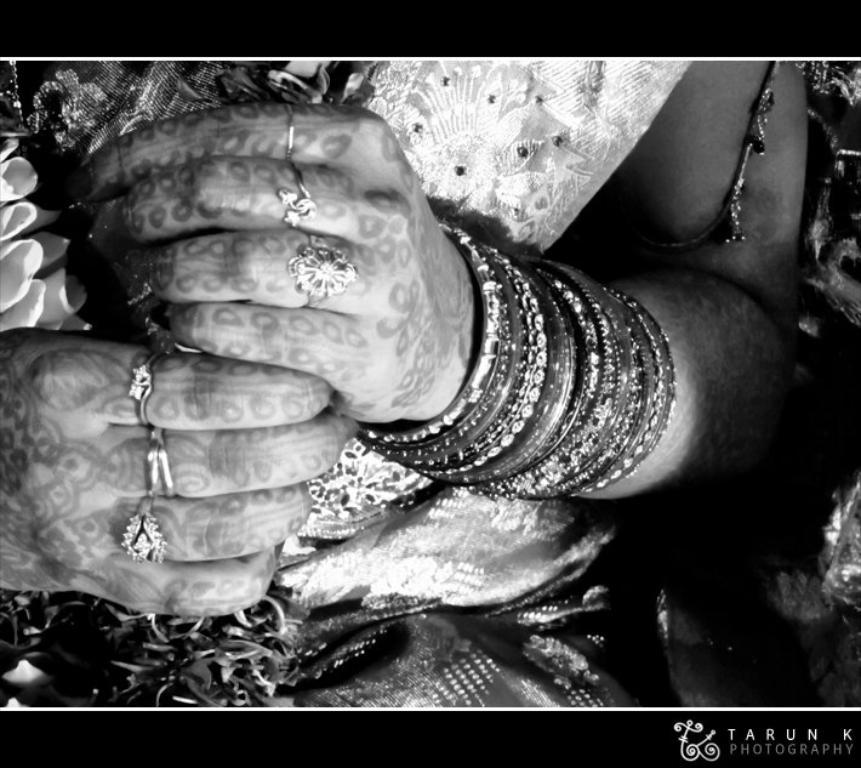What type of clothing is the person wearing in the image? The person is wearing a saree in the image. Are there any accessories visible in the image? Yes, the person is wearing a garland, bangles, and rings. Can you describe the lighting in the image? The image is slightly dark. What type of meat is the person holding in the image? There is no meat present in the image; the person is wearing a garland, bangles, and rings. What kind of tools might a carpenter use in the image? There are no tools or carpenters present in the image. 